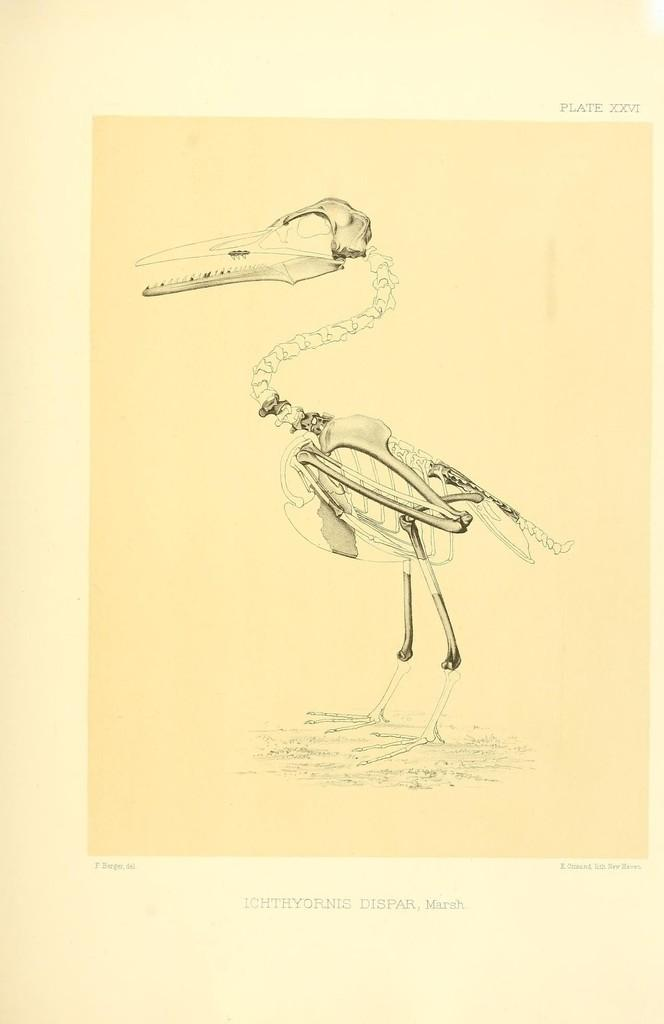What type of animal is depicted in the skeleton image in the picture? The skeleton image in the picture is of a bird. What type of advertisement is being displayed on the page in the image? There is no page or advertisement present in the image; it only contains a skeleton image of a bird. 